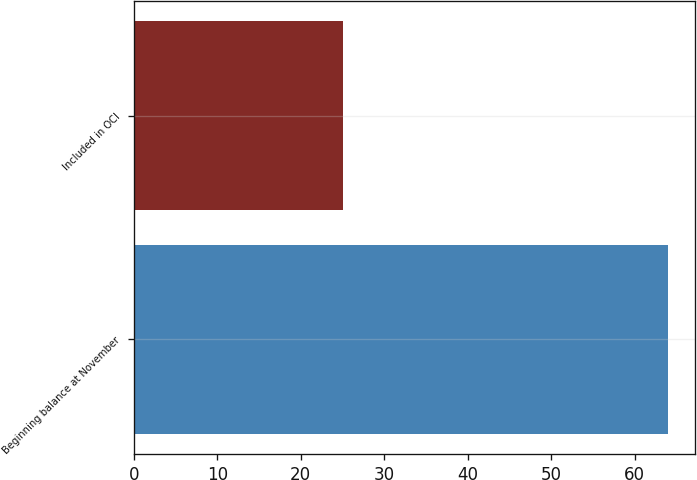Convert chart. <chart><loc_0><loc_0><loc_500><loc_500><bar_chart><fcel>Beginning balance at November<fcel>Included in OCI<nl><fcel>64<fcel>25<nl></chart> 